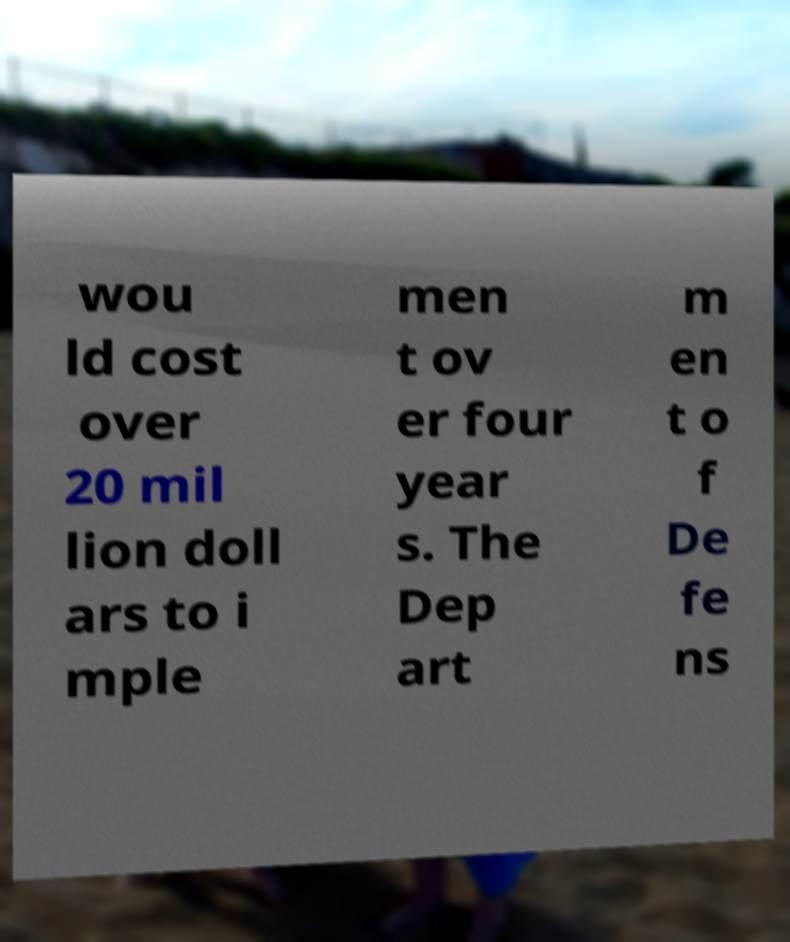Could you assist in decoding the text presented in this image and type it out clearly? wou ld cost over 20 mil lion doll ars to i mple men t ov er four year s. The Dep art m en t o f De fe ns 